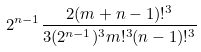<formula> <loc_0><loc_0><loc_500><loc_500>2 ^ { n - 1 } \frac { 2 ( m + n - 1 ) ! ^ { 3 } } { 3 ( 2 ^ { n - 1 } ) ^ { 3 } m ! ^ { 3 } ( n - 1 ) ! ^ { 3 } }</formula> 